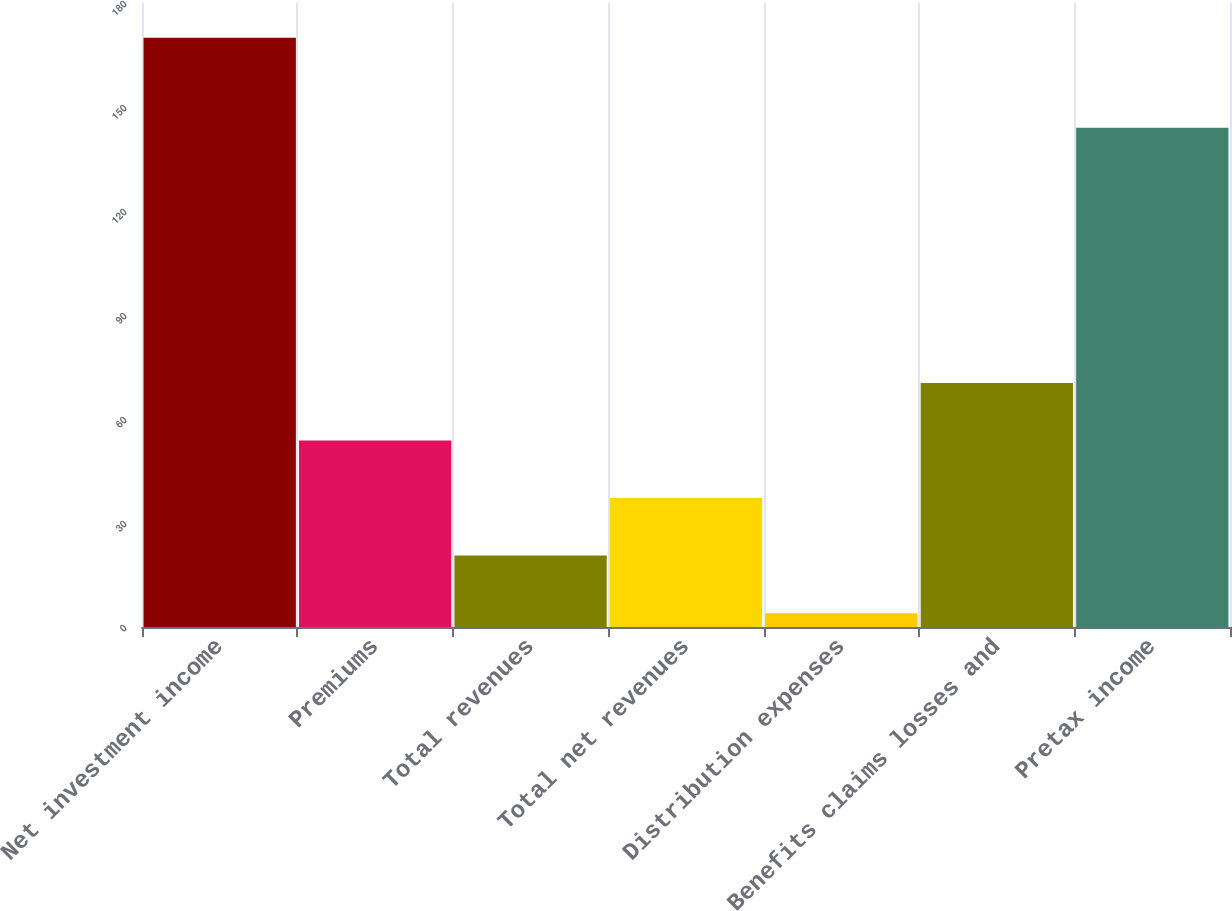Convert chart. <chart><loc_0><loc_0><loc_500><loc_500><bar_chart><fcel>Net investment income<fcel>Premiums<fcel>Total revenues<fcel>Total net revenues<fcel>Distribution expenses<fcel>Benefits claims losses and<fcel>Pretax income<nl><fcel>170<fcel>53.8<fcel>20.6<fcel>37.2<fcel>4<fcel>70.4<fcel>144<nl></chart> 